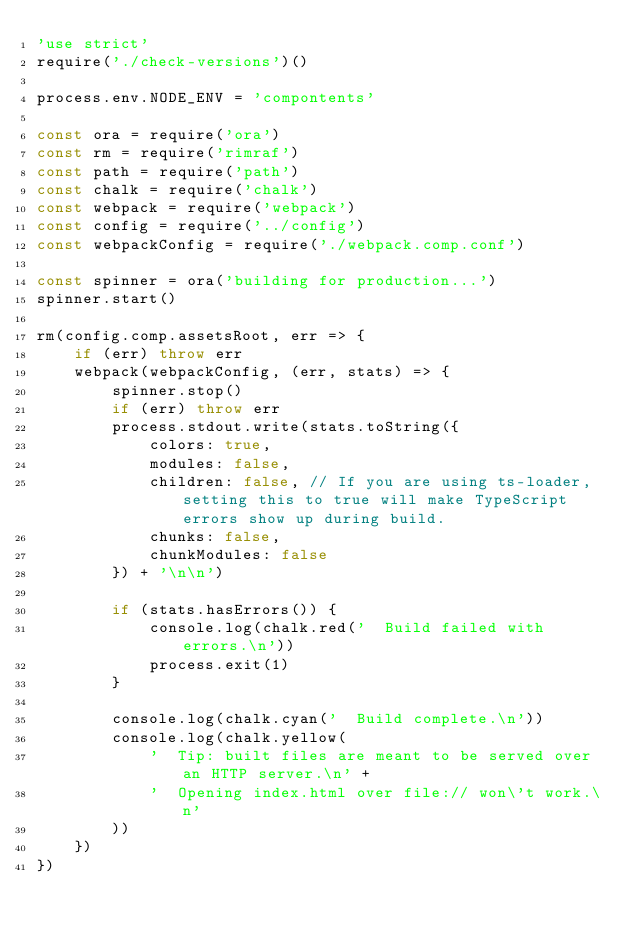<code> <loc_0><loc_0><loc_500><loc_500><_JavaScript_>'use strict'
require('./check-versions')()

process.env.NODE_ENV = 'compontents'

const ora = require('ora')
const rm = require('rimraf')
const path = require('path')
const chalk = require('chalk')
const webpack = require('webpack')
const config = require('../config')
const webpackConfig = require('./webpack.comp.conf')

const spinner = ora('building for production...')
spinner.start()

rm(config.comp.assetsRoot, err => {
    if (err) throw err
    webpack(webpackConfig, (err, stats) => {
        spinner.stop()
        if (err) throw err
        process.stdout.write(stats.toString({
            colors: true,
            modules: false,
            children: false, // If you are using ts-loader, setting this to true will make TypeScript errors show up during build.
            chunks: false,
            chunkModules: false
        }) + '\n\n')

        if (stats.hasErrors()) {
            console.log(chalk.red('  Build failed with errors.\n'))
            process.exit(1)
        }

        console.log(chalk.cyan('  Build complete.\n'))
        console.log(chalk.yellow(
            '  Tip: built files are meant to be served over an HTTP server.\n' +
            '  Opening index.html over file:// won\'t work.\n'
        ))
    })
})
</code> 